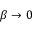<formula> <loc_0><loc_0><loc_500><loc_500>\beta \rightarrow 0</formula> 